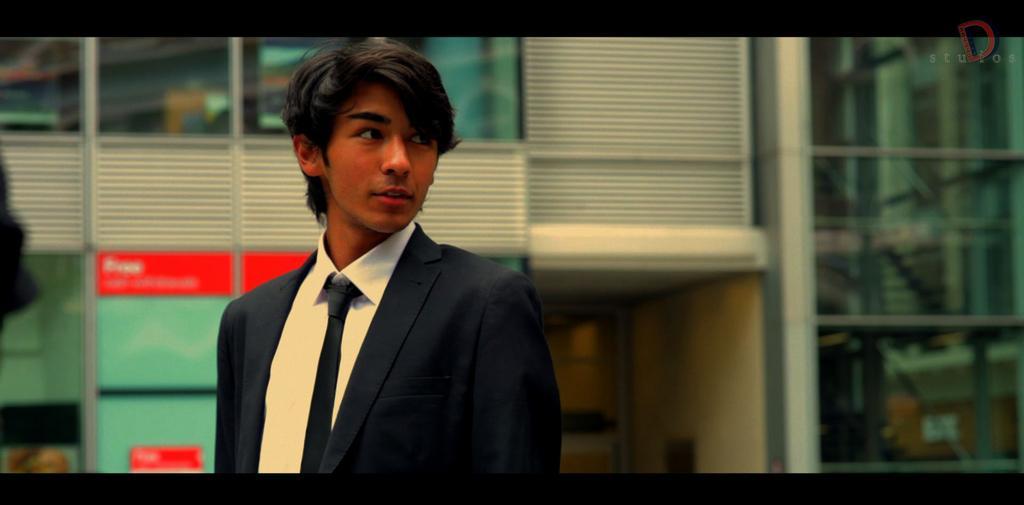Describe this image in one or two sentences. This image seems to be an edited image. In the background there is a building and there are a few boards. In the middle of the image there is a boy. He has worn a suit, a shirt and a tie. 